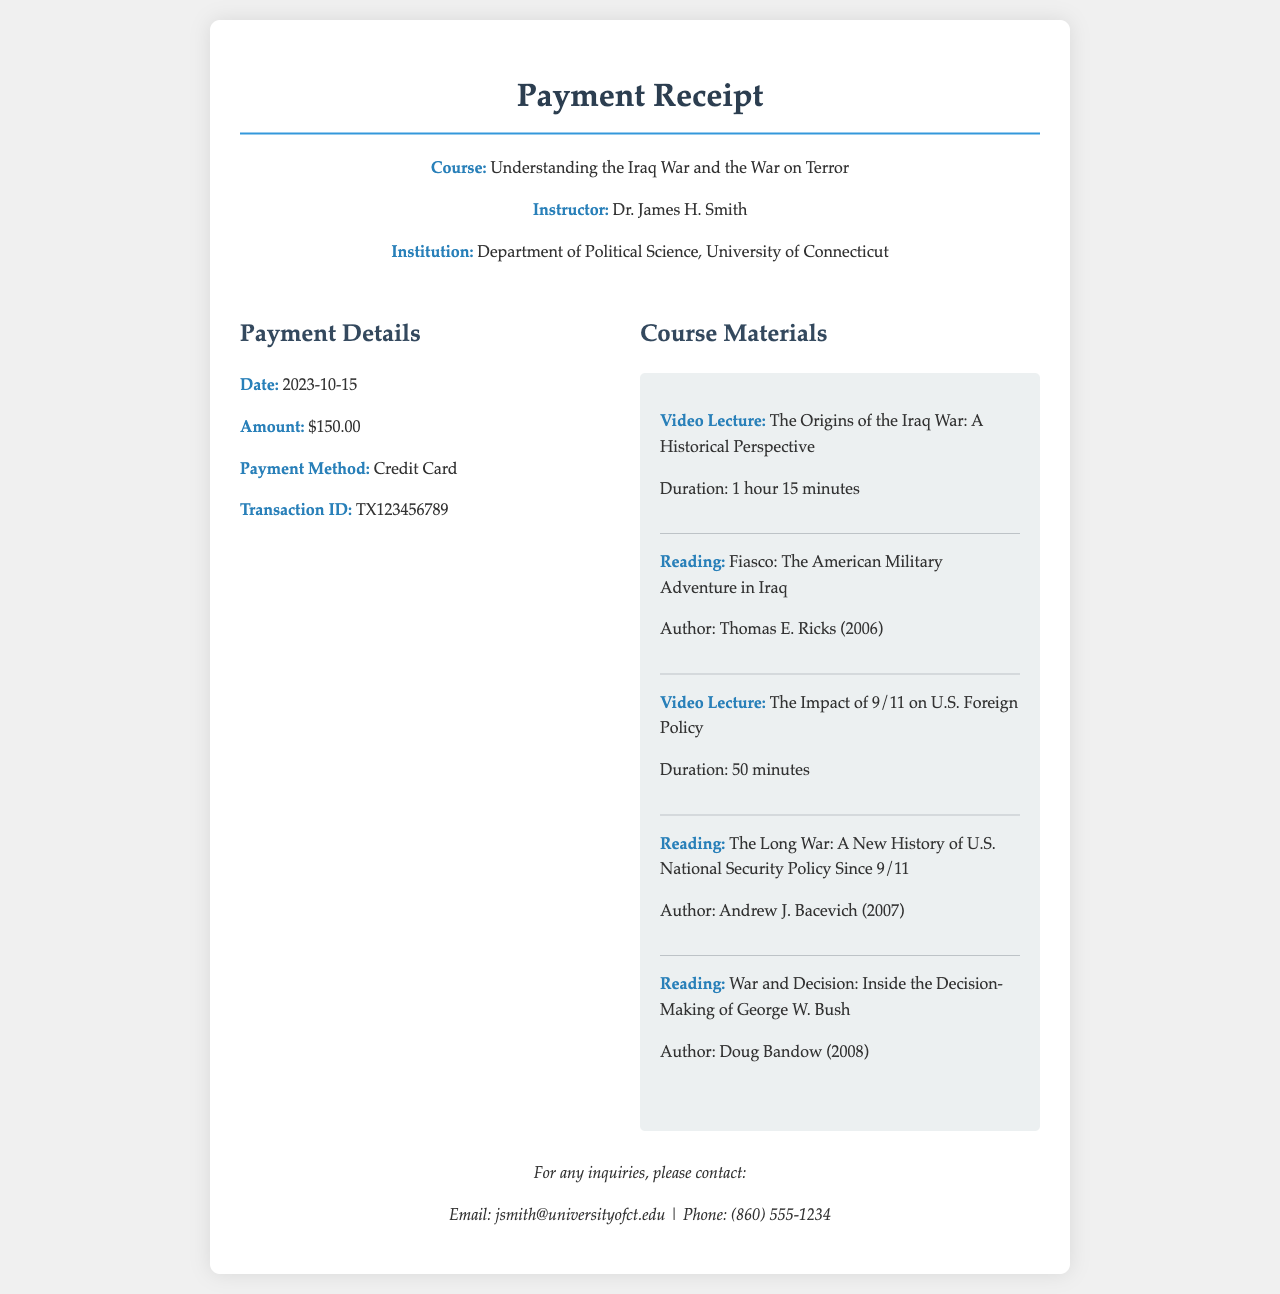What is the course title? The course title is provided at the beginning of the receipt, specifying the subject matter covered in the course.
Answer: Understanding the Iraq War and the War on Terror Who is the instructor? The instructor's name is mentioned alongside the course information at the top of the receipt.
Answer: Dr. James H. Smith What is the total payment amount? The total payment amount is detailed under the payment information section.
Answer: $150.00 When was the payment made? The payment date is specified in the payment details section of the receipt.
Answer: 2023-10-15 What payment method was used? The method of payment is indicated in the payment section, describing how the payment was rendered.
Answer: Credit Card How many video lectures are included? The number of video lectures can be determined by counting the video lecture items listed in the course materials.
Answer: 2 What is the title of the first reading? The title of the first reading is provided among the course materials.
Answer: Fiasco: The American Military Adventure in Iraq What is the duration of the second video lecture? The duration of the second video lecture is explicitly stated in the materials section.
Answer: 50 minutes What is the email contact for inquiries? The email address for inquiries is provided at the bottom of the receipt.
Answer: jsmith@universityofct.edu 